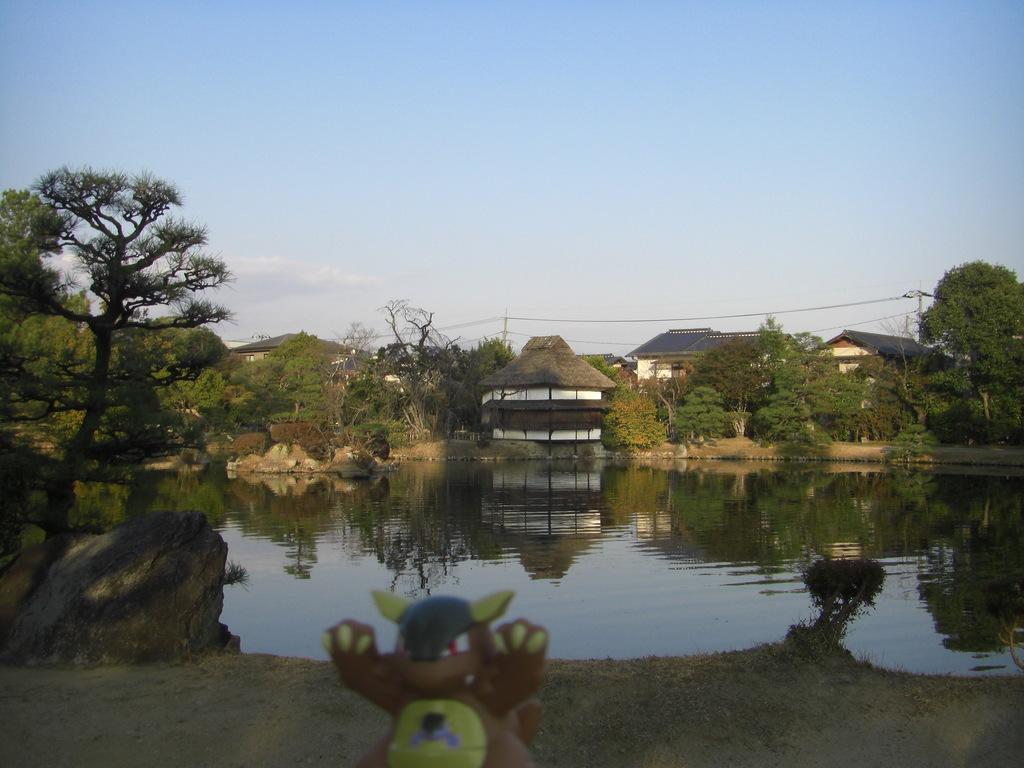Could you give a brief overview of what you see in this image? This image consists of a toy. At the bottom, there is a ground. In the middle, there is water. In the background, there are houses along with the trees. To the left, there is a rock. At the top, there is a sky. 